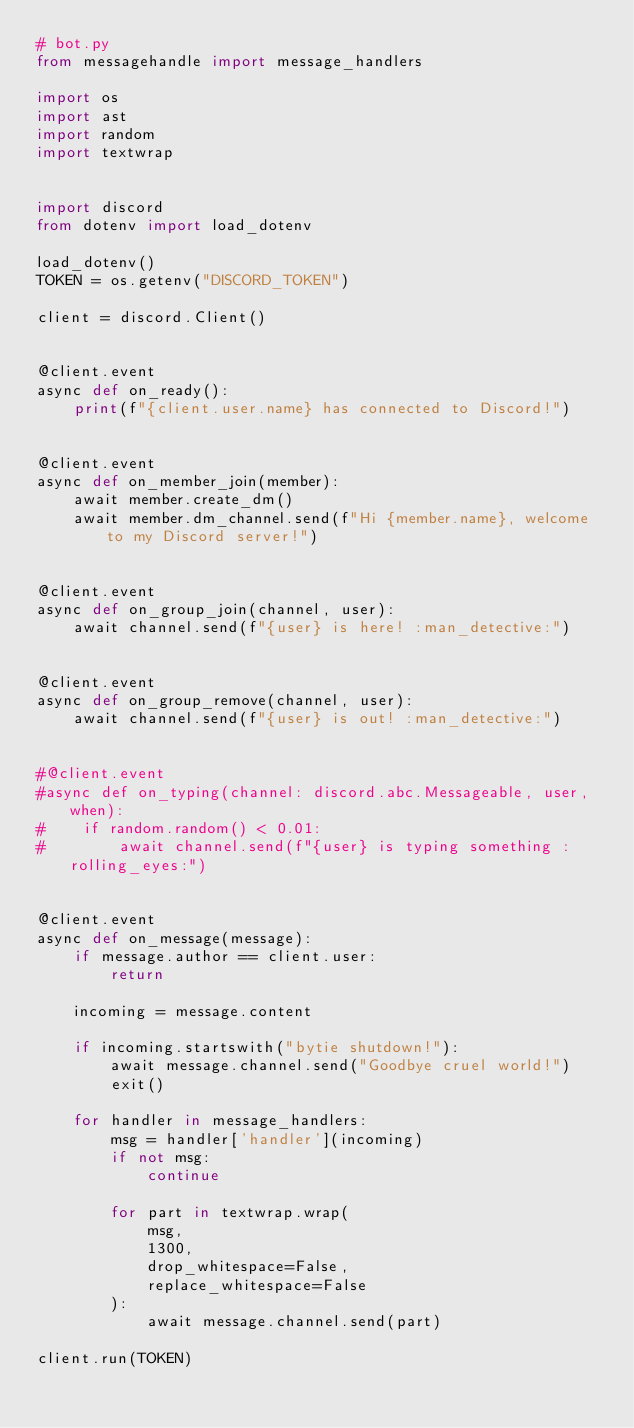<code> <loc_0><loc_0><loc_500><loc_500><_Python_># bot.py
from messagehandle import message_handlers

import os
import ast
import random
import textwrap


import discord
from dotenv import load_dotenv

load_dotenv()
TOKEN = os.getenv("DISCORD_TOKEN")

client = discord.Client()


@client.event
async def on_ready():
    print(f"{client.user.name} has connected to Discord!")


@client.event
async def on_member_join(member):
    await member.create_dm()
    await member.dm_channel.send(f"Hi {member.name}, welcome to my Discord server!")


@client.event
async def on_group_join(channel, user):
    await channel.send(f"{user} is here! :man_detective:")


@client.event
async def on_group_remove(channel, user):
    await channel.send(f"{user} is out! :man_detective:")


#@client.event
#async def on_typing(channel: discord.abc.Messageable, user, when):
#    if random.random() < 0.01:
#        await channel.send(f"{user} is typing something :rolling_eyes:")


@client.event
async def on_message(message):
    if message.author == client.user:
        return

    incoming = message.content

    if incoming.startswith("bytie shutdown!"):
        await message.channel.send("Goodbye cruel world!")
        exit()

    for handler in message_handlers:
        msg = handler['handler'](incoming)
        if not msg:
            continue

        for part in textwrap.wrap(
            msg,
            1300,
            drop_whitespace=False,
            replace_whitespace=False
        ):
            await message.channel.send(part)

client.run(TOKEN)
</code> 